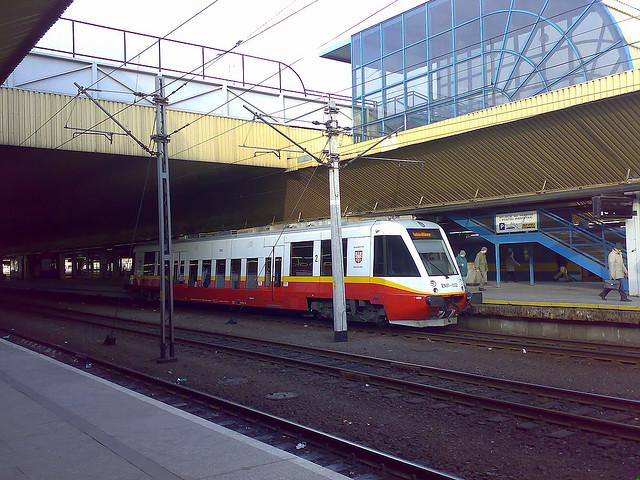What are the wires above the train used for? Please explain your reasoning. power. The wires are for power. 